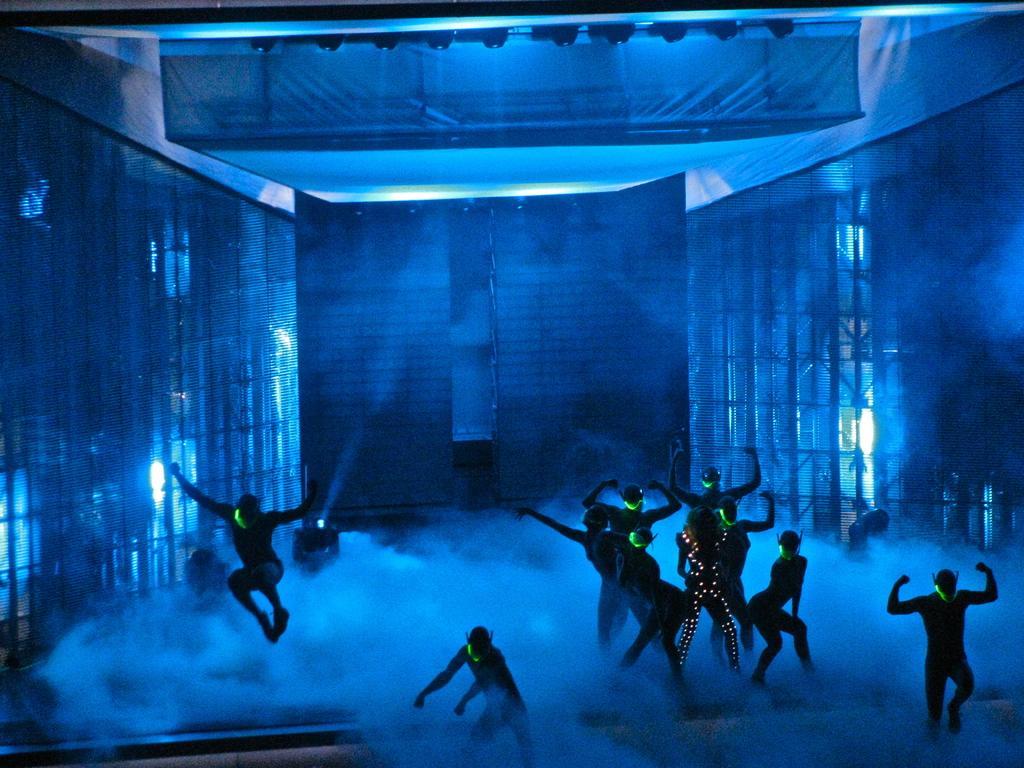Can you describe this image briefly? In this image there are some people in the costumes dancing on the stage, also there is some around. 